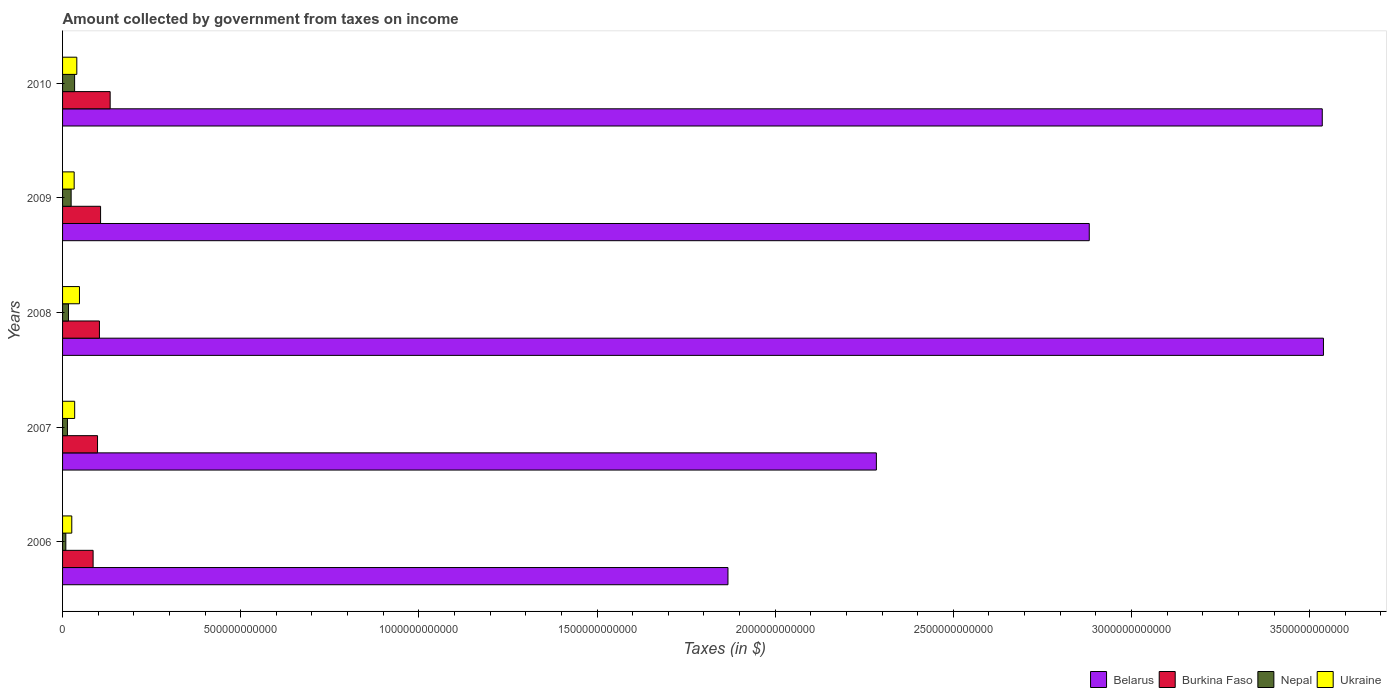Are the number of bars per tick equal to the number of legend labels?
Keep it short and to the point. Yes. How many bars are there on the 4th tick from the bottom?
Provide a short and direct response. 4. What is the amount collected by government from taxes on income in Ukraine in 2007?
Offer a terse response. 3.40e+1. Across all years, what is the maximum amount collected by government from taxes on income in Ukraine?
Your response must be concise. 4.75e+1. Across all years, what is the minimum amount collected by government from taxes on income in Belarus?
Give a very brief answer. 1.87e+12. In which year was the amount collected by government from taxes on income in Burkina Faso maximum?
Your answer should be very brief. 2010. What is the total amount collected by government from taxes on income in Ukraine in the graph?
Ensure brevity in your answer.  1.80e+11. What is the difference between the amount collected by government from taxes on income in Ukraine in 2006 and that in 2008?
Your response must be concise. -2.16e+1. What is the difference between the amount collected by government from taxes on income in Burkina Faso in 2006 and the amount collected by government from taxes on income in Nepal in 2009?
Provide a short and direct response. 6.17e+1. What is the average amount collected by government from taxes on income in Nepal per year?
Keep it short and to the point. 1.95e+1. In the year 2006, what is the difference between the amount collected by government from taxes on income in Burkina Faso and amount collected by government from taxes on income in Nepal?
Keep it short and to the point. 7.66e+1. What is the ratio of the amount collected by government from taxes on income in Nepal in 2007 to that in 2008?
Your answer should be compact. 0.83. Is the amount collected by government from taxes on income in Nepal in 2007 less than that in 2009?
Provide a short and direct response. Yes. What is the difference between the highest and the second highest amount collected by government from taxes on income in Ukraine?
Ensure brevity in your answer.  7.49e+09. What is the difference between the highest and the lowest amount collected by government from taxes on income in Ukraine?
Offer a terse response. 2.16e+1. In how many years, is the amount collected by government from taxes on income in Burkina Faso greater than the average amount collected by government from taxes on income in Burkina Faso taken over all years?
Provide a succinct answer. 2. Is the sum of the amount collected by government from taxes on income in Ukraine in 2006 and 2008 greater than the maximum amount collected by government from taxes on income in Belarus across all years?
Provide a short and direct response. No. Is it the case that in every year, the sum of the amount collected by government from taxes on income in Burkina Faso and amount collected by government from taxes on income in Ukraine is greater than the sum of amount collected by government from taxes on income in Belarus and amount collected by government from taxes on income in Nepal?
Keep it short and to the point. Yes. What does the 2nd bar from the top in 2008 represents?
Your answer should be very brief. Nepal. What does the 4th bar from the bottom in 2010 represents?
Your answer should be very brief. Ukraine. Is it the case that in every year, the sum of the amount collected by government from taxes on income in Belarus and amount collected by government from taxes on income in Ukraine is greater than the amount collected by government from taxes on income in Nepal?
Your answer should be compact. Yes. What is the difference between two consecutive major ticks on the X-axis?
Make the answer very short. 5.00e+11. Are the values on the major ticks of X-axis written in scientific E-notation?
Make the answer very short. No. Does the graph contain any zero values?
Keep it short and to the point. No. What is the title of the graph?
Your answer should be very brief. Amount collected by government from taxes on income. Does "Guyana" appear as one of the legend labels in the graph?
Make the answer very short. No. What is the label or title of the X-axis?
Make the answer very short. Taxes (in $). What is the Taxes (in $) in Belarus in 2006?
Your answer should be compact. 1.87e+12. What is the Taxes (in $) of Burkina Faso in 2006?
Provide a short and direct response. 8.57e+1. What is the Taxes (in $) in Nepal in 2006?
Keep it short and to the point. 9.16e+09. What is the Taxes (in $) in Ukraine in 2006?
Your answer should be compact. 2.59e+1. What is the Taxes (in $) of Belarus in 2007?
Provide a short and direct response. 2.28e+12. What is the Taxes (in $) in Burkina Faso in 2007?
Offer a very short reply. 9.82e+1. What is the Taxes (in $) in Nepal in 2007?
Provide a short and direct response. 1.37e+1. What is the Taxes (in $) of Ukraine in 2007?
Offer a very short reply. 3.40e+1. What is the Taxes (in $) in Belarus in 2008?
Provide a succinct answer. 3.54e+12. What is the Taxes (in $) in Burkina Faso in 2008?
Your answer should be compact. 1.03e+11. What is the Taxes (in $) in Nepal in 2008?
Provide a succinct answer. 1.66e+1. What is the Taxes (in $) of Ukraine in 2008?
Offer a terse response. 4.75e+1. What is the Taxes (in $) in Belarus in 2009?
Offer a very short reply. 2.88e+12. What is the Taxes (in $) in Burkina Faso in 2009?
Ensure brevity in your answer.  1.07e+11. What is the Taxes (in $) in Nepal in 2009?
Your response must be concise. 2.41e+1. What is the Taxes (in $) of Ukraine in 2009?
Your response must be concise. 3.26e+1. What is the Taxes (in $) of Belarus in 2010?
Your response must be concise. 3.54e+12. What is the Taxes (in $) in Burkina Faso in 2010?
Offer a very short reply. 1.34e+11. What is the Taxes (in $) in Nepal in 2010?
Provide a short and direct response. 3.38e+1. What is the Taxes (in $) in Ukraine in 2010?
Your response must be concise. 4.00e+1. Across all years, what is the maximum Taxes (in $) in Belarus?
Ensure brevity in your answer.  3.54e+12. Across all years, what is the maximum Taxes (in $) in Burkina Faso?
Provide a short and direct response. 1.34e+11. Across all years, what is the maximum Taxes (in $) of Nepal?
Provide a short and direct response. 3.38e+1. Across all years, what is the maximum Taxes (in $) in Ukraine?
Offer a very short reply. 4.75e+1. Across all years, what is the minimum Taxes (in $) in Belarus?
Your response must be concise. 1.87e+12. Across all years, what is the minimum Taxes (in $) in Burkina Faso?
Make the answer very short. 8.57e+1. Across all years, what is the minimum Taxes (in $) of Nepal?
Provide a short and direct response. 9.16e+09. Across all years, what is the minimum Taxes (in $) of Ukraine?
Make the answer very short. 2.59e+1. What is the total Taxes (in $) of Belarus in the graph?
Offer a very short reply. 1.41e+13. What is the total Taxes (in $) in Burkina Faso in the graph?
Your response must be concise. 5.28e+11. What is the total Taxes (in $) in Nepal in the graph?
Your answer should be compact. 9.74e+1. What is the total Taxes (in $) in Ukraine in the graph?
Your answer should be compact. 1.80e+11. What is the difference between the Taxes (in $) of Belarus in 2006 and that in 2007?
Provide a short and direct response. -4.16e+11. What is the difference between the Taxes (in $) in Burkina Faso in 2006 and that in 2007?
Provide a short and direct response. -1.24e+1. What is the difference between the Taxes (in $) of Nepal in 2006 and that in 2007?
Provide a succinct answer. -4.56e+09. What is the difference between the Taxes (in $) in Ukraine in 2006 and that in 2007?
Your answer should be very brief. -8.10e+09. What is the difference between the Taxes (in $) of Belarus in 2006 and that in 2008?
Your answer should be compact. -1.67e+12. What is the difference between the Taxes (in $) of Burkina Faso in 2006 and that in 2008?
Make the answer very short. -1.77e+1. What is the difference between the Taxes (in $) in Nepal in 2006 and that in 2008?
Provide a succinct answer. -7.46e+09. What is the difference between the Taxes (in $) in Ukraine in 2006 and that in 2008?
Offer a very short reply. -2.16e+1. What is the difference between the Taxes (in $) of Belarus in 2006 and that in 2009?
Offer a very short reply. -1.01e+12. What is the difference between the Taxes (in $) of Burkina Faso in 2006 and that in 2009?
Give a very brief answer. -2.09e+1. What is the difference between the Taxes (in $) in Nepal in 2006 and that in 2009?
Offer a terse response. -1.49e+1. What is the difference between the Taxes (in $) of Ukraine in 2006 and that in 2009?
Make the answer very short. -6.71e+09. What is the difference between the Taxes (in $) of Belarus in 2006 and that in 2010?
Provide a succinct answer. -1.67e+12. What is the difference between the Taxes (in $) of Burkina Faso in 2006 and that in 2010?
Your response must be concise. -4.78e+1. What is the difference between the Taxes (in $) of Nepal in 2006 and that in 2010?
Your response must be concise. -2.47e+1. What is the difference between the Taxes (in $) in Ukraine in 2006 and that in 2010?
Your answer should be very brief. -1.41e+1. What is the difference between the Taxes (in $) in Belarus in 2007 and that in 2008?
Make the answer very short. -1.25e+12. What is the difference between the Taxes (in $) of Burkina Faso in 2007 and that in 2008?
Give a very brief answer. -5.32e+09. What is the difference between the Taxes (in $) of Nepal in 2007 and that in 2008?
Keep it short and to the point. -2.90e+09. What is the difference between the Taxes (in $) of Ukraine in 2007 and that in 2008?
Keep it short and to the point. -1.35e+1. What is the difference between the Taxes (in $) of Belarus in 2007 and that in 2009?
Make the answer very short. -5.97e+11. What is the difference between the Taxes (in $) of Burkina Faso in 2007 and that in 2009?
Provide a succinct answer. -8.54e+09. What is the difference between the Taxes (in $) in Nepal in 2007 and that in 2009?
Your response must be concise. -1.03e+1. What is the difference between the Taxes (in $) of Ukraine in 2007 and that in 2009?
Your response must be concise. 1.39e+09. What is the difference between the Taxes (in $) in Belarus in 2007 and that in 2010?
Offer a very short reply. -1.25e+12. What is the difference between the Taxes (in $) in Burkina Faso in 2007 and that in 2010?
Your answer should be compact. -3.54e+1. What is the difference between the Taxes (in $) in Nepal in 2007 and that in 2010?
Your answer should be compact. -2.01e+1. What is the difference between the Taxes (in $) in Ukraine in 2007 and that in 2010?
Provide a succinct answer. -6.01e+09. What is the difference between the Taxes (in $) in Belarus in 2008 and that in 2009?
Keep it short and to the point. 6.57e+11. What is the difference between the Taxes (in $) in Burkina Faso in 2008 and that in 2009?
Your answer should be very brief. -3.22e+09. What is the difference between the Taxes (in $) in Nepal in 2008 and that in 2009?
Offer a very short reply. -7.42e+09. What is the difference between the Taxes (in $) in Ukraine in 2008 and that in 2009?
Give a very brief answer. 1.49e+1. What is the difference between the Taxes (in $) of Belarus in 2008 and that in 2010?
Offer a terse response. 3.34e+09. What is the difference between the Taxes (in $) in Burkina Faso in 2008 and that in 2010?
Your answer should be very brief. -3.01e+1. What is the difference between the Taxes (in $) of Nepal in 2008 and that in 2010?
Ensure brevity in your answer.  -1.72e+1. What is the difference between the Taxes (in $) of Ukraine in 2008 and that in 2010?
Offer a very short reply. 7.49e+09. What is the difference between the Taxes (in $) in Belarus in 2009 and that in 2010?
Ensure brevity in your answer.  -6.54e+11. What is the difference between the Taxes (in $) in Burkina Faso in 2009 and that in 2010?
Offer a very short reply. -2.69e+1. What is the difference between the Taxes (in $) of Nepal in 2009 and that in 2010?
Make the answer very short. -9.77e+09. What is the difference between the Taxes (in $) in Ukraine in 2009 and that in 2010?
Your answer should be very brief. -7.40e+09. What is the difference between the Taxes (in $) of Belarus in 2006 and the Taxes (in $) of Burkina Faso in 2007?
Ensure brevity in your answer.  1.77e+12. What is the difference between the Taxes (in $) of Belarus in 2006 and the Taxes (in $) of Nepal in 2007?
Ensure brevity in your answer.  1.85e+12. What is the difference between the Taxes (in $) of Belarus in 2006 and the Taxes (in $) of Ukraine in 2007?
Make the answer very short. 1.83e+12. What is the difference between the Taxes (in $) of Burkina Faso in 2006 and the Taxes (in $) of Nepal in 2007?
Offer a terse response. 7.20e+1. What is the difference between the Taxes (in $) of Burkina Faso in 2006 and the Taxes (in $) of Ukraine in 2007?
Give a very brief answer. 5.18e+1. What is the difference between the Taxes (in $) of Nepal in 2006 and the Taxes (in $) of Ukraine in 2007?
Your answer should be compact. -2.48e+1. What is the difference between the Taxes (in $) in Belarus in 2006 and the Taxes (in $) in Burkina Faso in 2008?
Your answer should be very brief. 1.76e+12. What is the difference between the Taxes (in $) of Belarus in 2006 and the Taxes (in $) of Nepal in 2008?
Provide a succinct answer. 1.85e+12. What is the difference between the Taxes (in $) of Belarus in 2006 and the Taxes (in $) of Ukraine in 2008?
Provide a short and direct response. 1.82e+12. What is the difference between the Taxes (in $) of Burkina Faso in 2006 and the Taxes (in $) of Nepal in 2008?
Keep it short and to the point. 6.91e+1. What is the difference between the Taxes (in $) in Burkina Faso in 2006 and the Taxes (in $) in Ukraine in 2008?
Your answer should be very brief. 3.83e+1. What is the difference between the Taxes (in $) of Nepal in 2006 and the Taxes (in $) of Ukraine in 2008?
Make the answer very short. -3.83e+1. What is the difference between the Taxes (in $) of Belarus in 2006 and the Taxes (in $) of Burkina Faso in 2009?
Offer a very short reply. 1.76e+12. What is the difference between the Taxes (in $) of Belarus in 2006 and the Taxes (in $) of Nepal in 2009?
Your answer should be compact. 1.84e+12. What is the difference between the Taxes (in $) in Belarus in 2006 and the Taxes (in $) in Ukraine in 2009?
Keep it short and to the point. 1.83e+12. What is the difference between the Taxes (in $) in Burkina Faso in 2006 and the Taxes (in $) in Nepal in 2009?
Your answer should be very brief. 6.17e+1. What is the difference between the Taxes (in $) in Burkina Faso in 2006 and the Taxes (in $) in Ukraine in 2009?
Your answer should be very brief. 5.32e+1. What is the difference between the Taxes (in $) of Nepal in 2006 and the Taxes (in $) of Ukraine in 2009?
Your answer should be very brief. -2.34e+1. What is the difference between the Taxes (in $) in Belarus in 2006 and the Taxes (in $) in Burkina Faso in 2010?
Your answer should be very brief. 1.73e+12. What is the difference between the Taxes (in $) of Belarus in 2006 and the Taxes (in $) of Nepal in 2010?
Give a very brief answer. 1.83e+12. What is the difference between the Taxes (in $) in Belarus in 2006 and the Taxes (in $) in Ukraine in 2010?
Your answer should be very brief. 1.83e+12. What is the difference between the Taxes (in $) of Burkina Faso in 2006 and the Taxes (in $) of Nepal in 2010?
Provide a succinct answer. 5.19e+1. What is the difference between the Taxes (in $) in Burkina Faso in 2006 and the Taxes (in $) in Ukraine in 2010?
Keep it short and to the point. 4.58e+1. What is the difference between the Taxes (in $) in Nepal in 2006 and the Taxes (in $) in Ukraine in 2010?
Provide a short and direct response. -3.08e+1. What is the difference between the Taxes (in $) in Belarus in 2007 and the Taxes (in $) in Burkina Faso in 2008?
Your answer should be compact. 2.18e+12. What is the difference between the Taxes (in $) of Belarus in 2007 and the Taxes (in $) of Nepal in 2008?
Give a very brief answer. 2.27e+12. What is the difference between the Taxes (in $) in Belarus in 2007 and the Taxes (in $) in Ukraine in 2008?
Your answer should be very brief. 2.24e+12. What is the difference between the Taxes (in $) in Burkina Faso in 2007 and the Taxes (in $) in Nepal in 2008?
Ensure brevity in your answer.  8.15e+1. What is the difference between the Taxes (in $) in Burkina Faso in 2007 and the Taxes (in $) in Ukraine in 2008?
Ensure brevity in your answer.  5.07e+1. What is the difference between the Taxes (in $) of Nepal in 2007 and the Taxes (in $) of Ukraine in 2008?
Your response must be concise. -3.37e+1. What is the difference between the Taxes (in $) of Belarus in 2007 and the Taxes (in $) of Burkina Faso in 2009?
Keep it short and to the point. 2.18e+12. What is the difference between the Taxes (in $) in Belarus in 2007 and the Taxes (in $) in Nepal in 2009?
Offer a very short reply. 2.26e+12. What is the difference between the Taxes (in $) of Belarus in 2007 and the Taxes (in $) of Ukraine in 2009?
Keep it short and to the point. 2.25e+12. What is the difference between the Taxes (in $) in Burkina Faso in 2007 and the Taxes (in $) in Nepal in 2009?
Offer a terse response. 7.41e+1. What is the difference between the Taxes (in $) of Burkina Faso in 2007 and the Taxes (in $) of Ukraine in 2009?
Your response must be concise. 6.56e+1. What is the difference between the Taxes (in $) in Nepal in 2007 and the Taxes (in $) in Ukraine in 2009?
Provide a short and direct response. -1.88e+1. What is the difference between the Taxes (in $) in Belarus in 2007 and the Taxes (in $) in Burkina Faso in 2010?
Keep it short and to the point. 2.15e+12. What is the difference between the Taxes (in $) of Belarus in 2007 and the Taxes (in $) of Nepal in 2010?
Give a very brief answer. 2.25e+12. What is the difference between the Taxes (in $) in Belarus in 2007 and the Taxes (in $) in Ukraine in 2010?
Your answer should be compact. 2.24e+12. What is the difference between the Taxes (in $) of Burkina Faso in 2007 and the Taxes (in $) of Nepal in 2010?
Give a very brief answer. 6.43e+1. What is the difference between the Taxes (in $) of Burkina Faso in 2007 and the Taxes (in $) of Ukraine in 2010?
Offer a terse response. 5.82e+1. What is the difference between the Taxes (in $) in Nepal in 2007 and the Taxes (in $) in Ukraine in 2010?
Offer a very short reply. -2.62e+1. What is the difference between the Taxes (in $) in Belarus in 2008 and the Taxes (in $) in Burkina Faso in 2009?
Offer a terse response. 3.43e+12. What is the difference between the Taxes (in $) in Belarus in 2008 and the Taxes (in $) in Nepal in 2009?
Provide a succinct answer. 3.51e+12. What is the difference between the Taxes (in $) in Belarus in 2008 and the Taxes (in $) in Ukraine in 2009?
Give a very brief answer. 3.51e+12. What is the difference between the Taxes (in $) in Burkina Faso in 2008 and the Taxes (in $) in Nepal in 2009?
Give a very brief answer. 7.94e+1. What is the difference between the Taxes (in $) in Burkina Faso in 2008 and the Taxes (in $) in Ukraine in 2009?
Provide a short and direct response. 7.09e+1. What is the difference between the Taxes (in $) of Nepal in 2008 and the Taxes (in $) of Ukraine in 2009?
Offer a terse response. -1.59e+1. What is the difference between the Taxes (in $) of Belarus in 2008 and the Taxes (in $) of Burkina Faso in 2010?
Your answer should be very brief. 3.41e+12. What is the difference between the Taxes (in $) of Belarus in 2008 and the Taxes (in $) of Nepal in 2010?
Keep it short and to the point. 3.50e+12. What is the difference between the Taxes (in $) of Belarus in 2008 and the Taxes (in $) of Ukraine in 2010?
Ensure brevity in your answer.  3.50e+12. What is the difference between the Taxes (in $) in Burkina Faso in 2008 and the Taxes (in $) in Nepal in 2010?
Your answer should be very brief. 6.96e+1. What is the difference between the Taxes (in $) of Burkina Faso in 2008 and the Taxes (in $) of Ukraine in 2010?
Keep it short and to the point. 6.35e+1. What is the difference between the Taxes (in $) in Nepal in 2008 and the Taxes (in $) in Ukraine in 2010?
Ensure brevity in your answer.  -2.33e+1. What is the difference between the Taxes (in $) in Belarus in 2009 and the Taxes (in $) in Burkina Faso in 2010?
Your answer should be compact. 2.75e+12. What is the difference between the Taxes (in $) of Belarus in 2009 and the Taxes (in $) of Nepal in 2010?
Keep it short and to the point. 2.85e+12. What is the difference between the Taxes (in $) in Belarus in 2009 and the Taxes (in $) in Ukraine in 2010?
Give a very brief answer. 2.84e+12. What is the difference between the Taxes (in $) of Burkina Faso in 2009 and the Taxes (in $) of Nepal in 2010?
Your answer should be very brief. 7.29e+1. What is the difference between the Taxes (in $) of Burkina Faso in 2009 and the Taxes (in $) of Ukraine in 2010?
Your answer should be compact. 6.67e+1. What is the difference between the Taxes (in $) in Nepal in 2009 and the Taxes (in $) in Ukraine in 2010?
Your answer should be compact. -1.59e+1. What is the average Taxes (in $) of Belarus per year?
Offer a terse response. 2.82e+12. What is the average Taxes (in $) in Burkina Faso per year?
Your response must be concise. 1.06e+11. What is the average Taxes (in $) of Nepal per year?
Give a very brief answer. 1.95e+1. What is the average Taxes (in $) of Ukraine per year?
Ensure brevity in your answer.  3.60e+1. In the year 2006, what is the difference between the Taxes (in $) in Belarus and Taxes (in $) in Burkina Faso?
Provide a succinct answer. 1.78e+12. In the year 2006, what is the difference between the Taxes (in $) in Belarus and Taxes (in $) in Nepal?
Your answer should be compact. 1.86e+12. In the year 2006, what is the difference between the Taxes (in $) of Belarus and Taxes (in $) of Ukraine?
Ensure brevity in your answer.  1.84e+12. In the year 2006, what is the difference between the Taxes (in $) in Burkina Faso and Taxes (in $) in Nepal?
Your response must be concise. 7.66e+1. In the year 2006, what is the difference between the Taxes (in $) in Burkina Faso and Taxes (in $) in Ukraine?
Your response must be concise. 5.99e+1. In the year 2006, what is the difference between the Taxes (in $) in Nepal and Taxes (in $) in Ukraine?
Provide a short and direct response. -1.67e+1. In the year 2007, what is the difference between the Taxes (in $) of Belarus and Taxes (in $) of Burkina Faso?
Your answer should be compact. 2.19e+12. In the year 2007, what is the difference between the Taxes (in $) of Belarus and Taxes (in $) of Nepal?
Make the answer very short. 2.27e+12. In the year 2007, what is the difference between the Taxes (in $) in Belarus and Taxes (in $) in Ukraine?
Keep it short and to the point. 2.25e+12. In the year 2007, what is the difference between the Taxes (in $) of Burkina Faso and Taxes (in $) of Nepal?
Make the answer very short. 8.44e+1. In the year 2007, what is the difference between the Taxes (in $) in Burkina Faso and Taxes (in $) in Ukraine?
Provide a short and direct response. 6.42e+1. In the year 2007, what is the difference between the Taxes (in $) in Nepal and Taxes (in $) in Ukraine?
Offer a terse response. -2.02e+1. In the year 2008, what is the difference between the Taxes (in $) in Belarus and Taxes (in $) in Burkina Faso?
Offer a terse response. 3.44e+12. In the year 2008, what is the difference between the Taxes (in $) of Belarus and Taxes (in $) of Nepal?
Offer a very short reply. 3.52e+12. In the year 2008, what is the difference between the Taxes (in $) in Belarus and Taxes (in $) in Ukraine?
Your answer should be very brief. 3.49e+12. In the year 2008, what is the difference between the Taxes (in $) of Burkina Faso and Taxes (in $) of Nepal?
Keep it short and to the point. 8.68e+1. In the year 2008, what is the difference between the Taxes (in $) in Burkina Faso and Taxes (in $) in Ukraine?
Your answer should be compact. 5.60e+1. In the year 2008, what is the difference between the Taxes (in $) of Nepal and Taxes (in $) of Ukraine?
Your answer should be compact. -3.08e+1. In the year 2009, what is the difference between the Taxes (in $) of Belarus and Taxes (in $) of Burkina Faso?
Your response must be concise. 2.77e+12. In the year 2009, what is the difference between the Taxes (in $) of Belarus and Taxes (in $) of Nepal?
Your answer should be compact. 2.86e+12. In the year 2009, what is the difference between the Taxes (in $) of Belarus and Taxes (in $) of Ukraine?
Make the answer very short. 2.85e+12. In the year 2009, what is the difference between the Taxes (in $) of Burkina Faso and Taxes (in $) of Nepal?
Give a very brief answer. 8.26e+1. In the year 2009, what is the difference between the Taxes (in $) in Burkina Faso and Taxes (in $) in Ukraine?
Make the answer very short. 7.41e+1. In the year 2009, what is the difference between the Taxes (in $) of Nepal and Taxes (in $) of Ukraine?
Give a very brief answer. -8.52e+09. In the year 2010, what is the difference between the Taxes (in $) in Belarus and Taxes (in $) in Burkina Faso?
Your answer should be very brief. 3.40e+12. In the year 2010, what is the difference between the Taxes (in $) in Belarus and Taxes (in $) in Nepal?
Ensure brevity in your answer.  3.50e+12. In the year 2010, what is the difference between the Taxes (in $) of Belarus and Taxes (in $) of Ukraine?
Give a very brief answer. 3.50e+12. In the year 2010, what is the difference between the Taxes (in $) of Burkina Faso and Taxes (in $) of Nepal?
Make the answer very short. 9.98e+1. In the year 2010, what is the difference between the Taxes (in $) of Burkina Faso and Taxes (in $) of Ukraine?
Make the answer very short. 9.36e+1. In the year 2010, what is the difference between the Taxes (in $) in Nepal and Taxes (in $) in Ukraine?
Keep it short and to the point. -6.15e+09. What is the ratio of the Taxes (in $) in Belarus in 2006 to that in 2007?
Offer a very short reply. 0.82. What is the ratio of the Taxes (in $) of Burkina Faso in 2006 to that in 2007?
Give a very brief answer. 0.87. What is the ratio of the Taxes (in $) of Nepal in 2006 to that in 2007?
Your answer should be very brief. 0.67. What is the ratio of the Taxes (in $) in Ukraine in 2006 to that in 2007?
Your response must be concise. 0.76. What is the ratio of the Taxes (in $) of Belarus in 2006 to that in 2008?
Ensure brevity in your answer.  0.53. What is the ratio of the Taxes (in $) of Burkina Faso in 2006 to that in 2008?
Your answer should be very brief. 0.83. What is the ratio of the Taxes (in $) of Nepal in 2006 to that in 2008?
Provide a short and direct response. 0.55. What is the ratio of the Taxes (in $) in Ukraine in 2006 to that in 2008?
Ensure brevity in your answer.  0.55. What is the ratio of the Taxes (in $) in Belarus in 2006 to that in 2009?
Your answer should be very brief. 0.65. What is the ratio of the Taxes (in $) in Burkina Faso in 2006 to that in 2009?
Offer a very short reply. 0.8. What is the ratio of the Taxes (in $) in Nepal in 2006 to that in 2009?
Offer a very short reply. 0.38. What is the ratio of the Taxes (in $) of Ukraine in 2006 to that in 2009?
Offer a terse response. 0.79. What is the ratio of the Taxes (in $) in Belarus in 2006 to that in 2010?
Ensure brevity in your answer.  0.53. What is the ratio of the Taxes (in $) of Burkina Faso in 2006 to that in 2010?
Give a very brief answer. 0.64. What is the ratio of the Taxes (in $) of Nepal in 2006 to that in 2010?
Your answer should be very brief. 0.27. What is the ratio of the Taxes (in $) of Ukraine in 2006 to that in 2010?
Ensure brevity in your answer.  0.65. What is the ratio of the Taxes (in $) in Belarus in 2007 to that in 2008?
Provide a succinct answer. 0.65. What is the ratio of the Taxes (in $) in Burkina Faso in 2007 to that in 2008?
Your answer should be compact. 0.95. What is the ratio of the Taxes (in $) of Nepal in 2007 to that in 2008?
Give a very brief answer. 0.83. What is the ratio of the Taxes (in $) in Ukraine in 2007 to that in 2008?
Offer a terse response. 0.72. What is the ratio of the Taxes (in $) of Belarus in 2007 to that in 2009?
Your answer should be very brief. 0.79. What is the ratio of the Taxes (in $) in Nepal in 2007 to that in 2009?
Provide a short and direct response. 0.57. What is the ratio of the Taxes (in $) of Ukraine in 2007 to that in 2009?
Your answer should be very brief. 1.04. What is the ratio of the Taxes (in $) in Belarus in 2007 to that in 2010?
Provide a succinct answer. 0.65. What is the ratio of the Taxes (in $) of Burkina Faso in 2007 to that in 2010?
Ensure brevity in your answer.  0.73. What is the ratio of the Taxes (in $) in Nepal in 2007 to that in 2010?
Keep it short and to the point. 0.41. What is the ratio of the Taxes (in $) in Ukraine in 2007 to that in 2010?
Provide a succinct answer. 0.85. What is the ratio of the Taxes (in $) of Belarus in 2008 to that in 2009?
Make the answer very short. 1.23. What is the ratio of the Taxes (in $) in Burkina Faso in 2008 to that in 2009?
Your answer should be compact. 0.97. What is the ratio of the Taxes (in $) of Nepal in 2008 to that in 2009?
Your answer should be compact. 0.69. What is the ratio of the Taxes (in $) of Ukraine in 2008 to that in 2009?
Give a very brief answer. 1.46. What is the ratio of the Taxes (in $) of Burkina Faso in 2008 to that in 2010?
Offer a terse response. 0.77. What is the ratio of the Taxes (in $) in Nepal in 2008 to that in 2010?
Your answer should be very brief. 0.49. What is the ratio of the Taxes (in $) in Ukraine in 2008 to that in 2010?
Your answer should be compact. 1.19. What is the ratio of the Taxes (in $) of Belarus in 2009 to that in 2010?
Keep it short and to the point. 0.81. What is the ratio of the Taxes (in $) in Burkina Faso in 2009 to that in 2010?
Your answer should be very brief. 0.8. What is the ratio of the Taxes (in $) in Nepal in 2009 to that in 2010?
Provide a short and direct response. 0.71. What is the ratio of the Taxes (in $) of Ukraine in 2009 to that in 2010?
Ensure brevity in your answer.  0.81. What is the difference between the highest and the second highest Taxes (in $) in Belarus?
Provide a short and direct response. 3.34e+09. What is the difference between the highest and the second highest Taxes (in $) in Burkina Faso?
Your response must be concise. 2.69e+1. What is the difference between the highest and the second highest Taxes (in $) of Nepal?
Provide a succinct answer. 9.77e+09. What is the difference between the highest and the second highest Taxes (in $) of Ukraine?
Provide a succinct answer. 7.49e+09. What is the difference between the highest and the lowest Taxes (in $) in Belarus?
Your answer should be very brief. 1.67e+12. What is the difference between the highest and the lowest Taxes (in $) in Burkina Faso?
Your response must be concise. 4.78e+1. What is the difference between the highest and the lowest Taxes (in $) in Nepal?
Make the answer very short. 2.47e+1. What is the difference between the highest and the lowest Taxes (in $) of Ukraine?
Offer a very short reply. 2.16e+1. 